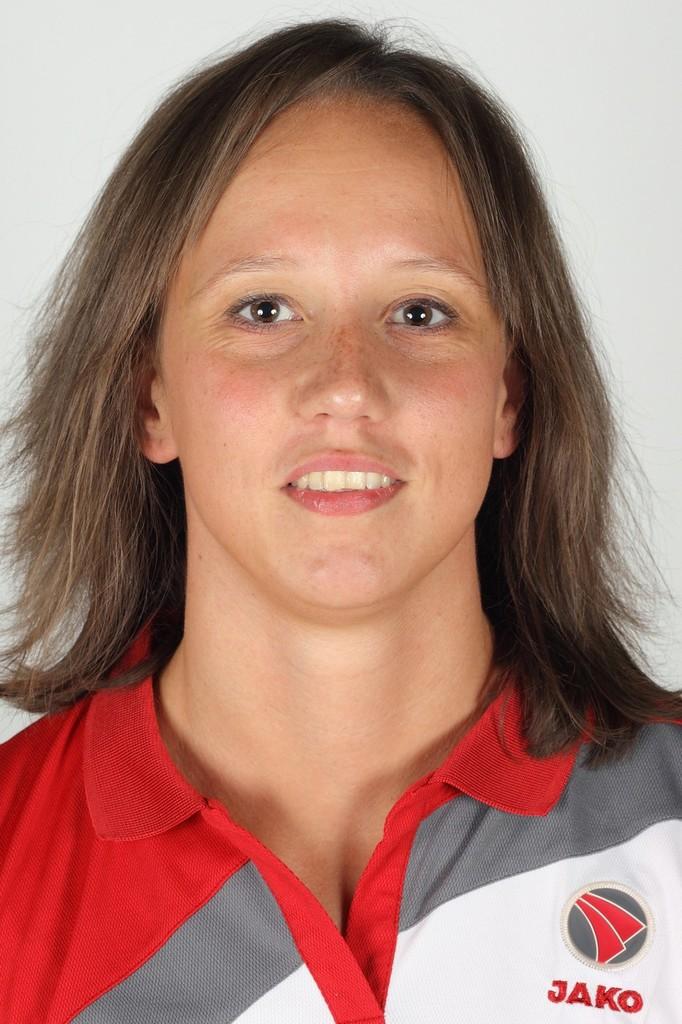What's written on the shirt?
Ensure brevity in your answer.  Jako. 